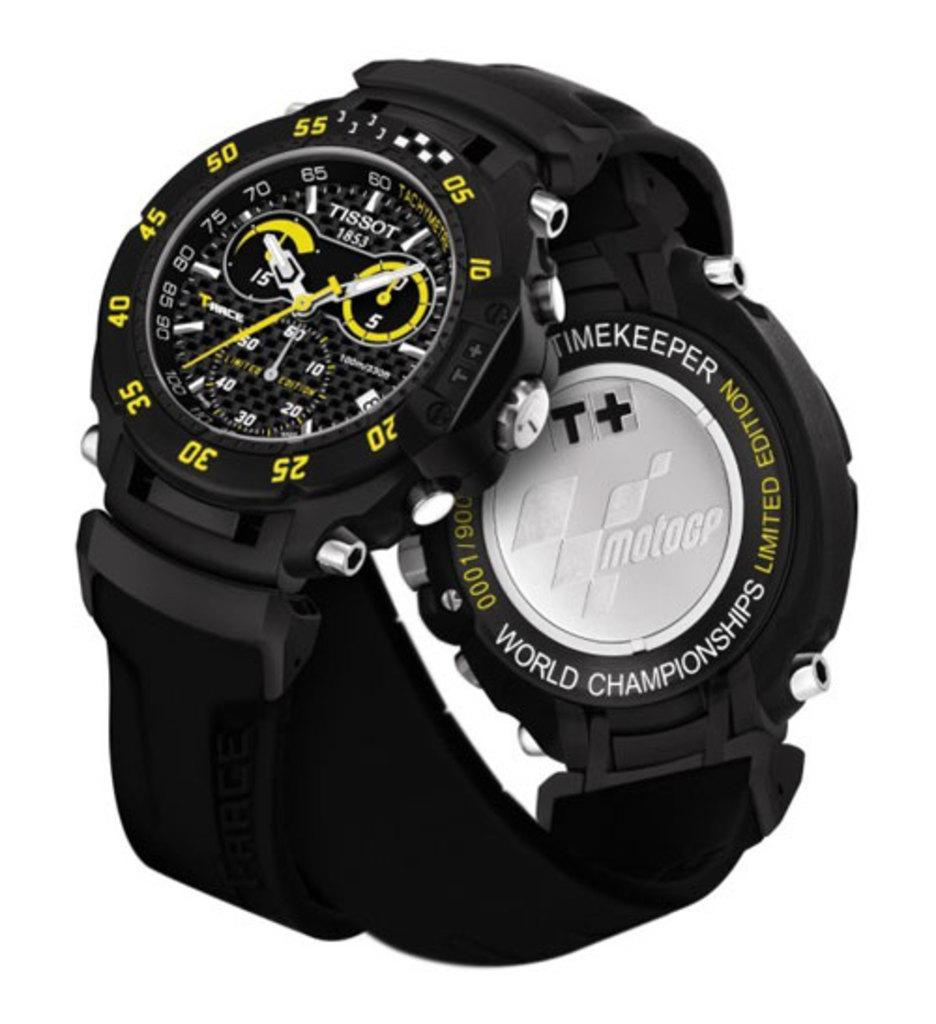<image>
Render a clear and concise summary of the photo. A black, white and yellow Tissot 1852 World Championships Limited Edition watch. 